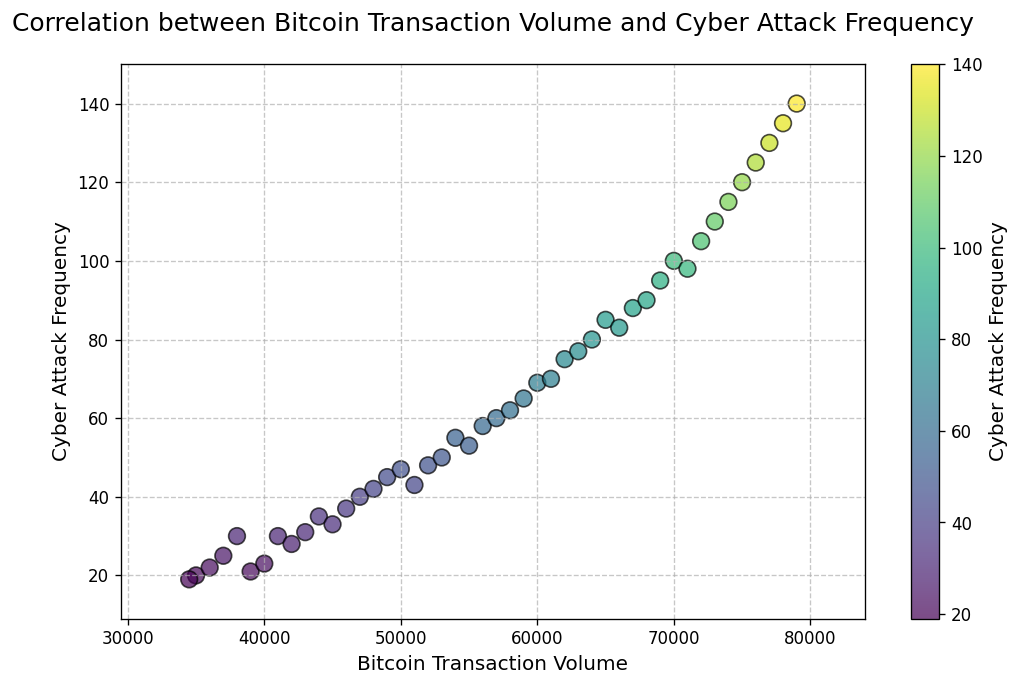What is the title of the scatter plot? The title of the scatter plot is displayed prominently at the top of the figure. Reading it shows that it is "Correlation between Bitcoin Transaction Volume and Cyber Attack Frequency".
Answer: Correlation between Bitcoin Transaction Volume and Cyber Attack Frequency What is represented by the x-axis and y-axis? The labels along the horizontal axis (x-axis) and the vertical axis (y-axis) indicate what each axis represents. The x-axis is labeled "Bitcoin Transaction Volume" and the y-axis is labeled "Cyber Attack Frequency".
Answer: Bitcoin Transaction Volume and Cyber Attack Frequency Does the scatter plot indicate a positive correlation between Bitcoin transaction volume and cyber attack frequency? By observing the trend in the scatter plot, we can notice that as the Bitcoin transaction volume increases, the cyber attack frequency also increases. The points tend to move in an upward direction.
Answer: Yes Which month has the highest cyber attack frequency, and what is the Bitcoin transaction volume for that month? By looking for the highest point on the y-axis and checking the corresponding x-axis value, the largest y-value corresponds to Cyber Attack Frequency 140. The Bitcoin Transaction Volume for this point is 79,000.
Answer: October 2023, 79,000 How does the cyber attack frequency in January 2023 compare to that in May 2023? Locate the points corresponding to January 2023 and May 2023. January 2023 has a cyber attack frequency of 100, while May 2023 has 115. We can see that the frequency in May 2023 is higher.
Answer: May 2023 has a higher frequency What range of Bitcoin transaction volume is represented in the scatter plot? Examine the limits on the x-axis to find the range. The x-axis starts at 30,000 and extends to 80,000. Taking into account the buffer added to the axes' limits, the range can be seen from 30,000 to 80,000.
Answer: 30,000 to 80,000 Is there any specific month when Bitcoin transaction volume had a sudden spike along with an increase in cyber attack frequency? By identifying any sharp upward trends or spikes in the scatter plot, we notice that the volume rapidly increases around August 2021, which also shows a corresponding increase in cyber attacks.
Answer: August 2021 What is the color of the dot representing the highest cyber attack frequency, and what does it indicate? The color mapping of the scatter plot shows the gradient represented in the color bar. The highest frequency dot (140) has a color near the maximum value on the color bar, indicating a high number of cyber attacks. Generally, it would be a color near the top of the viridis color map (dark or bright part).
Answer: Dark or bright color (depends on viridis colormap) From the scatter plot, if the Bitcoin volume is 50,000, what approximate cyber attack frequency can be expected? Locate the x-axis value closest to 50,000 and identify the corresponding y-axis value. The point near 50,000 for Bitcoin transaction volume approximately shows a cyber attack frequency near 47.
Answer: 47 